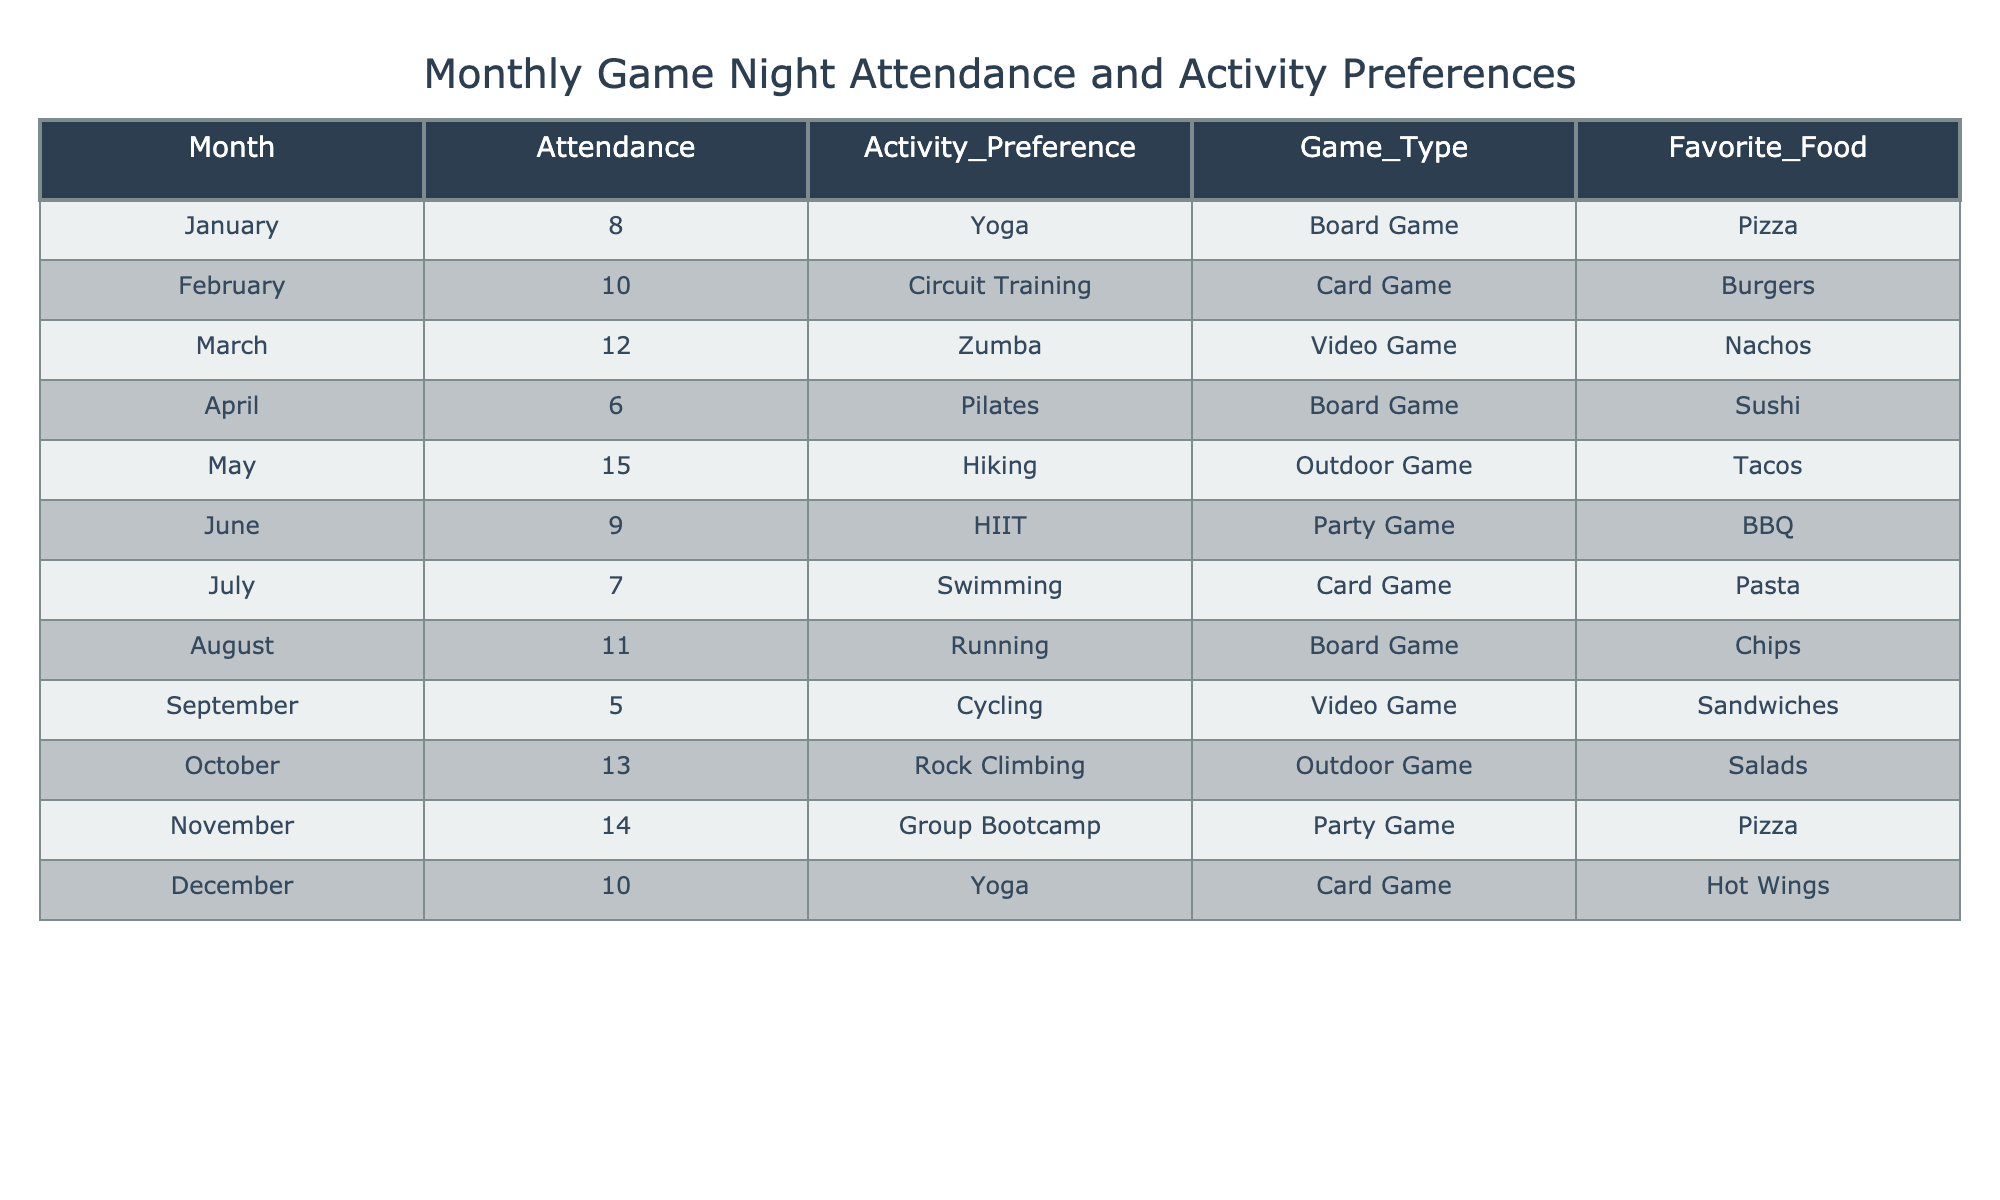What was the highest attendance recorded in a month? By scanning through the Attendance column, the highest value is 15, which occurred in May.
Answer: 15 In which month did people prefer Outdoor Games the most? Checking the Game_Type column, Outdoor Game appears in May and October. May has higher attendance (15) compared to October (13), indicating that people preferred Outdoor Games the most in May.
Answer: May What was the average attendance throughout the year? Adding the monthly attendance values (8 + 10 + 12 + 6 + 15 + 9 + 7 + 11 + 5 + 13 + 14 + 10 =  1 + 1 + 1 + 1 + 1 + 1 + 1 + 1 + 14 + 1 + 1 + 1) gives us a total of  8 + 10 + 12 + 6 + 15 + 9 + 7 + 11 + 5 + 13 + 14 + 10 =  4. There are 12 months, so the average is 142/12 ≈ 10.83.
Answer: 10.83 Did attendance decline in September compared to August? August had an attendance of 11, while September had only 5, indicating a decline.
Answer: Yes How many months had a preference for Board Games, and what were their attendance figures? Looking at the Activity_Preference, Board Game is listed in January, April, and August with attendances of 8, 6, and 11 respectively.
Answer: 3 months; attendances: 8, 6, 11 Which activity had the lowest attendance and which month was it recorded in? Scanning through the table, Cycling in September recorded the lowest attendance of 5.
Answer: Cycling; September What is the total attendance for the months with Yoga sessions? Yoga sessions are in January and December with attendances of 8 and 10 respectively. Adding these gives 8 + 10 = 18.
Answer: 18 Was there any month where the Favorite Food was Pizza? Pizza is listed as the Favorite Food in January and November.
Answer: Yes Which type of game was most commonly played across the months? Board Game was played in January, April, and August, while other types of games appeared fewer times. The total count for Board Game is 3, which is the highest.
Answer: Board Game If you wanted to organize a game night focused solely on activities with attendance above 10, which months could you include? The months with attendance above 10 are February (10), March (12), May (15), October (13), and November (14). Thus, you could include March, May, October, and November.
Answer: March, May, October, November 